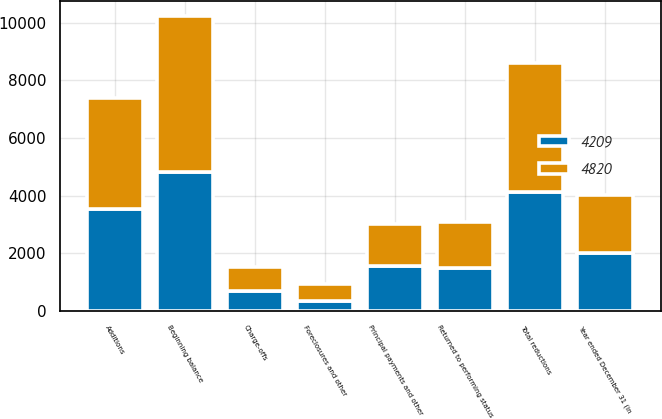Convert chart. <chart><loc_0><loc_0><loc_500><loc_500><stacked_bar_chart><ecel><fcel>Year ended December 31 (in<fcel>Beginning balance<fcel>Additions<fcel>Principal payments and other<fcel>Charge-offs<fcel>Returned to performing status<fcel>Foreclosures and other<fcel>Total reductions<nl><fcel>4209<fcel>2017<fcel>4820<fcel>3525<fcel>1577<fcel>699<fcel>1509<fcel>351<fcel>4136<nl><fcel>4820<fcel>2016<fcel>5413<fcel>3858<fcel>1437<fcel>843<fcel>1589<fcel>582<fcel>4451<nl></chart> 